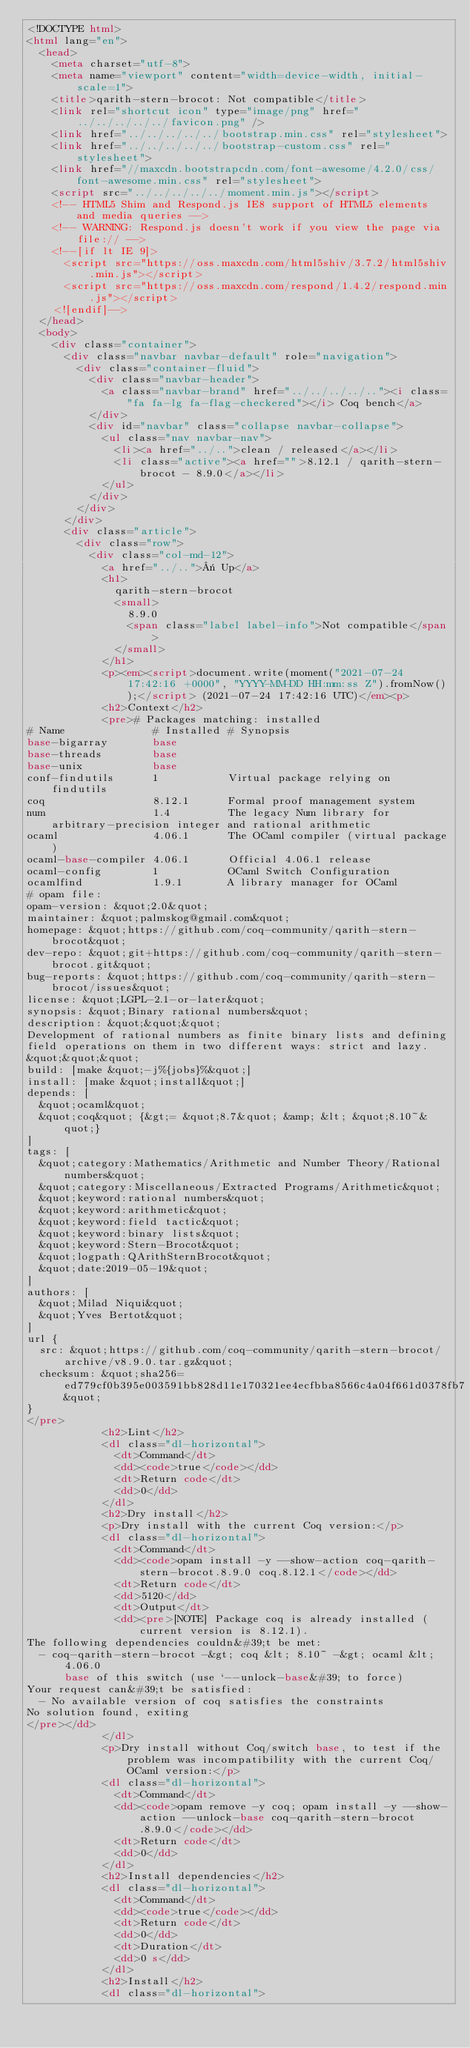<code> <loc_0><loc_0><loc_500><loc_500><_HTML_><!DOCTYPE html>
<html lang="en">
  <head>
    <meta charset="utf-8">
    <meta name="viewport" content="width=device-width, initial-scale=1">
    <title>qarith-stern-brocot: Not compatible</title>
    <link rel="shortcut icon" type="image/png" href="../../../../../favicon.png" />
    <link href="../../../../../bootstrap.min.css" rel="stylesheet">
    <link href="../../../../../bootstrap-custom.css" rel="stylesheet">
    <link href="//maxcdn.bootstrapcdn.com/font-awesome/4.2.0/css/font-awesome.min.css" rel="stylesheet">
    <script src="../../../../../moment.min.js"></script>
    <!-- HTML5 Shim and Respond.js IE8 support of HTML5 elements and media queries -->
    <!-- WARNING: Respond.js doesn't work if you view the page via file:// -->
    <!--[if lt IE 9]>
      <script src="https://oss.maxcdn.com/html5shiv/3.7.2/html5shiv.min.js"></script>
      <script src="https://oss.maxcdn.com/respond/1.4.2/respond.min.js"></script>
    <![endif]-->
  </head>
  <body>
    <div class="container">
      <div class="navbar navbar-default" role="navigation">
        <div class="container-fluid">
          <div class="navbar-header">
            <a class="navbar-brand" href="../../../../.."><i class="fa fa-lg fa-flag-checkered"></i> Coq bench</a>
          </div>
          <div id="navbar" class="collapse navbar-collapse">
            <ul class="nav navbar-nav">
              <li><a href="../..">clean / released</a></li>
              <li class="active"><a href="">8.12.1 / qarith-stern-brocot - 8.9.0</a></li>
            </ul>
          </div>
        </div>
      </div>
      <div class="article">
        <div class="row">
          <div class="col-md-12">
            <a href="../..">« Up</a>
            <h1>
              qarith-stern-brocot
              <small>
                8.9.0
                <span class="label label-info">Not compatible</span>
              </small>
            </h1>
            <p><em><script>document.write(moment("2021-07-24 17:42:16 +0000", "YYYY-MM-DD HH:mm:ss Z").fromNow());</script> (2021-07-24 17:42:16 UTC)</em><p>
            <h2>Context</h2>
            <pre># Packages matching: installed
# Name              # Installed # Synopsis
base-bigarray       base
base-threads        base
base-unix           base
conf-findutils      1           Virtual package relying on findutils
coq                 8.12.1      Formal proof management system
num                 1.4         The legacy Num library for arbitrary-precision integer and rational arithmetic
ocaml               4.06.1      The OCaml compiler (virtual package)
ocaml-base-compiler 4.06.1      Official 4.06.1 release
ocaml-config        1           OCaml Switch Configuration
ocamlfind           1.9.1       A library manager for OCaml
# opam file:
opam-version: &quot;2.0&quot;
maintainer: &quot;palmskog@gmail.com&quot;
homepage: &quot;https://github.com/coq-community/qarith-stern-brocot&quot;
dev-repo: &quot;git+https://github.com/coq-community/qarith-stern-brocot.git&quot;
bug-reports: &quot;https://github.com/coq-community/qarith-stern-brocot/issues&quot;
license: &quot;LGPL-2.1-or-later&quot;
synopsis: &quot;Binary rational numbers&quot;
description: &quot;&quot;&quot;
Development of rational numbers as finite binary lists and defining
field operations on them in two different ways: strict and lazy.
&quot;&quot;&quot;
build: [make &quot;-j%{jobs}%&quot;]
install: [make &quot;install&quot;]
depends: [
  &quot;ocaml&quot;
  &quot;coq&quot; {&gt;= &quot;8.7&quot; &amp; &lt; &quot;8.10~&quot;}
]
tags: [
  &quot;category:Mathematics/Arithmetic and Number Theory/Rational numbers&quot;
  &quot;category:Miscellaneous/Extracted Programs/Arithmetic&quot;
  &quot;keyword:rational numbers&quot;
  &quot;keyword:arithmetic&quot;
  &quot;keyword:field tactic&quot;
  &quot;keyword:binary lists&quot;
  &quot;keyword:Stern-Brocot&quot;
  &quot;logpath:QArithSternBrocot&quot;
  &quot;date:2019-05-19&quot;
]
authors: [
  &quot;Milad Niqui&quot;
  &quot;Yves Bertot&quot;
]
url {
  src: &quot;https://github.com/coq-community/qarith-stern-brocot/archive/v8.9.0.tar.gz&quot;
  checksum: &quot;sha256=ed779cf0b395e003591bb828d11e170321ee4ecfbba8566c4a04f661d0378fb7&quot;
}
</pre>
            <h2>Lint</h2>
            <dl class="dl-horizontal">
              <dt>Command</dt>
              <dd><code>true</code></dd>
              <dt>Return code</dt>
              <dd>0</dd>
            </dl>
            <h2>Dry install</h2>
            <p>Dry install with the current Coq version:</p>
            <dl class="dl-horizontal">
              <dt>Command</dt>
              <dd><code>opam install -y --show-action coq-qarith-stern-brocot.8.9.0 coq.8.12.1</code></dd>
              <dt>Return code</dt>
              <dd>5120</dd>
              <dt>Output</dt>
              <dd><pre>[NOTE] Package coq is already installed (current version is 8.12.1).
The following dependencies couldn&#39;t be met:
  - coq-qarith-stern-brocot -&gt; coq &lt; 8.10~ -&gt; ocaml &lt; 4.06.0
      base of this switch (use `--unlock-base&#39; to force)
Your request can&#39;t be satisfied:
  - No available version of coq satisfies the constraints
No solution found, exiting
</pre></dd>
            </dl>
            <p>Dry install without Coq/switch base, to test if the problem was incompatibility with the current Coq/OCaml version:</p>
            <dl class="dl-horizontal">
              <dt>Command</dt>
              <dd><code>opam remove -y coq; opam install -y --show-action --unlock-base coq-qarith-stern-brocot.8.9.0</code></dd>
              <dt>Return code</dt>
              <dd>0</dd>
            </dl>
            <h2>Install dependencies</h2>
            <dl class="dl-horizontal">
              <dt>Command</dt>
              <dd><code>true</code></dd>
              <dt>Return code</dt>
              <dd>0</dd>
              <dt>Duration</dt>
              <dd>0 s</dd>
            </dl>
            <h2>Install</h2>
            <dl class="dl-horizontal"></code> 